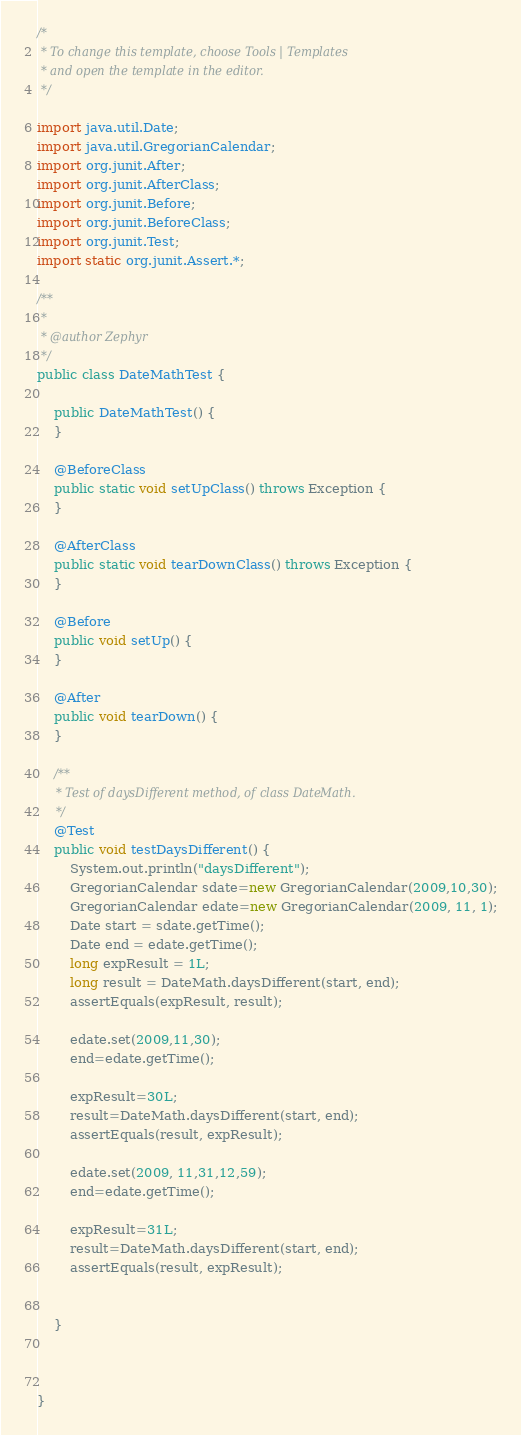<code> <loc_0><loc_0><loc_500><loc_500><_Java_>/*
 * To change this template, choose Tools | Templates
 * and open the template in the editor.
 */

import java.util.Date;
import java.util.GregorianCalendar;
import org.junit.After;
import org.junit.AfterClass;
import org.junit.Before;
import org.junit.BeforeClass;
import org.junit.Test;
import static org.junit.Assert.*;

/**
 *
 * @author Zephyr
 */
public class DateMathTest {

    public DateMathTest() {
    }

    @BeforeClass
    public static void setUpClass() throws Exception {
    }

    @AfterClass
    public static void tearDownClass() throws Exception {
    }

    @Before
    public void setUp() {
    }

    @After
    public void tearDown() {
    }

    /**
     * Test of daysDifferent method, of class DateMath.
     */
    @Test
    public void testDaysDifferent() {
        System.out.println("daysDifferent");
        GregorianCalendar sdate=new GregorianCalendar(2009,10,30);
        GregorianCalendar edate=new GregorianCalendar(2009, 11, 1);
        Date start = sdate.getTime();
        Date end = edate.getTime();
        long expResult = 1L;
        long result = DateMath.daysDifferent(start, end);
        assertEquals(expResult, result);

        edate.set(2009,11,30);
        end=edate.getTime();

        expResult=30L;
        result=DateMath.daysDifferent(start, end);
        assertEquals(result, expResult);

        edate.set(2009, 11,31,12,59);
        end=edate.getTime();

        expResult=31L;
        result=DateMath.daysDifferent(start, end);
        assertEquals(result, expResult);


    }

    

}</code> 